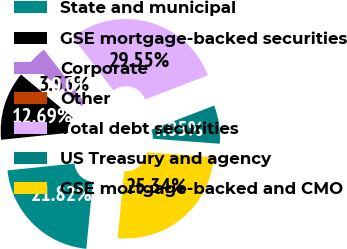<chart> <loc_0><loc_0><loc_500><loc_500><pie_chart><fcel>State and municipal<fcel>GSE mortgage-backed securities<fcel>Corporate<fcel>Other<fcel>Total debt securities<fcel>US Treasury and agency<fcel>GSE mortgage-backed and CMO<nl><fcel>21.82%<fcel>12.69%<fcel>3.53%<fcel>0.01%<fcel>29.55%<fcel>7.05%<fcel>25.34%<nl></chart> 